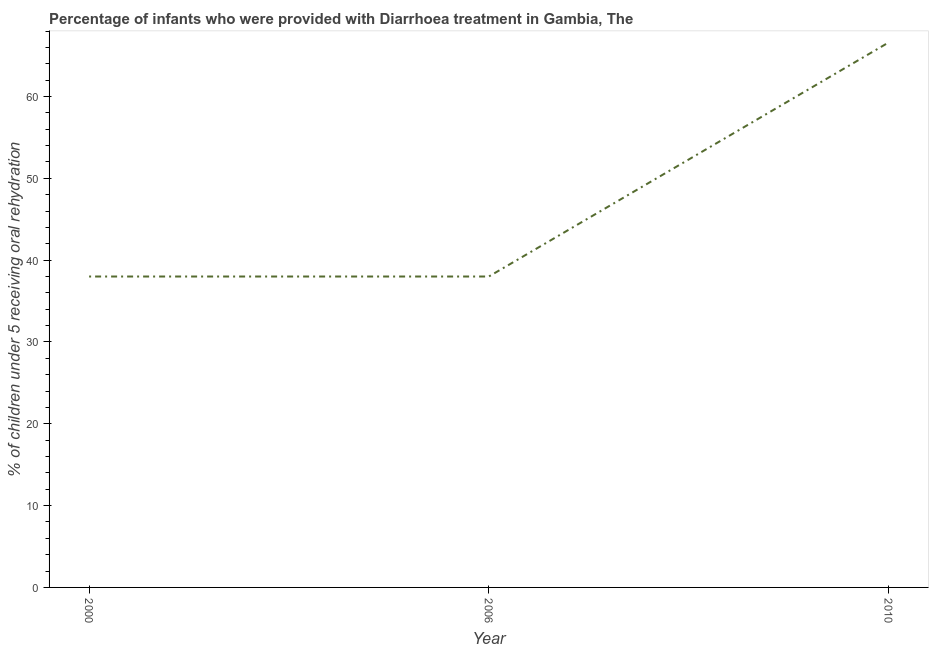Across all years, what is the maximum percentage of children who were provided with treatment diarrhoea?
Make the answer very short. 66.6. Across all years, what is the minimum percentage of children who were provided with treatment diarrhoea?
Give a very brief answer. 38. In which year was the percentage of children who were provided with treatment diarrhoea maximum?
Your response must be concise. 2010. In which year was the percentage of children who were provided with treatment diarrhoea minimum?
Give a very brief answer. 2000. What is the sum of the percentage of children who were provided with treatment diarrhoea?
Ensure brevity in your answer.  142.6. What is the difference between the percentage of children who were provided with treatment diarrhoea in 2000 and 2010?
Offer a very short reply. -28.6. What is the average percentage of children who were provided with treatment diarrhoea per year?
Offer a terse response. 47.53. In how many years, is the percentage of children who were provided with treatment diarrhoea greater than 46 %?
Your response must be concise. 1. Is the percentage of children who were provided with treatment diarrhoea in 2000 less than that in 2010?
Make the answer very short. Yes. What is the difference between the highest and the second highest percentage of children who were provided with treatment diarrhoea?
Your response must be concise. 28.6. Is the sum of the percentage of children who were provided with treatment diarrhoea in 2000 and 2010 greater than the maximum percentage of children who were provided with treatment diarrhoea across all years?
Ensure brevity in your answer.  Yes. What is the difference between the highest and the lowest percentage of children who were provided with treatment diarrhoea?
Keep it short and to the point. 28.6. Does the percentage of children who were provided with treatment diarrhoea monotonically increase over the years?
Provide a short and direct response. No. What is the title of the graph?
Offer a terse response. Percentage of infants who were provided with Diarrhoea treatment in Gambia, The. What is the label or title of the X-axis?
Offer a very short reply. Year. What is the label or title of the Y-axis?
Provide a succinct answer. % of children under 5 receiving oral rehydration. What is the % of children under 5 receiving oral rehydration of 2006?
Ensure brevity in your answer.  38. What is the % of children under 5 receiving oral rehydration in 2010?
Provide a succinct answer. 66.6. What is the difference between the % of children under 5 receiving oral rehydration in 2000 and 2010?
Provide a succinct answer. -28.6. What is the difference between the % of children under 5 receiving oral rehydration in 2006 and 2010?
Your answer should be very brief. -28.6. What is the ratio of the % of children under 5 receiving oral rehydration in 2000 to that in 2010?
Your answer should be compact. 0.57. What is the ratio of the % of children under 5 receiving oral rehydration in 2006 to that in 2010?
Offer a terse response. 0.57. 